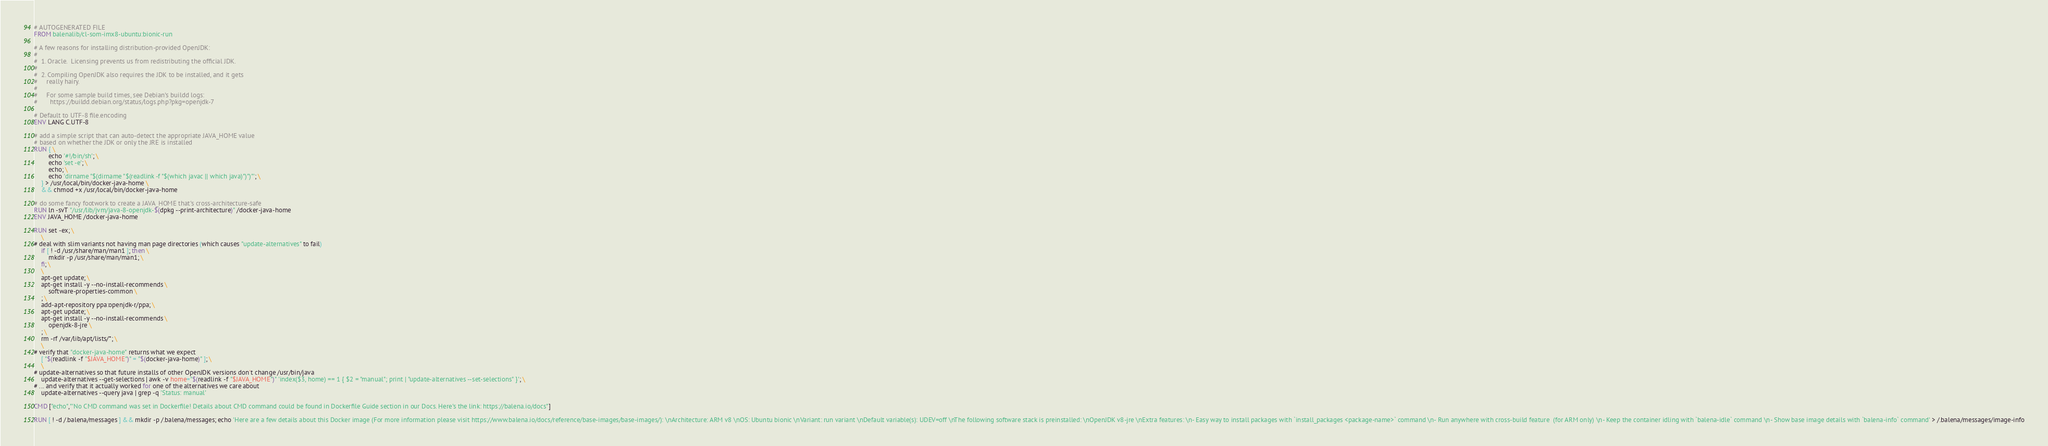Convert code to text. <code><loc_0><loc_0><loc_500><loc_500><_Dockerfile_># AUTOGENERATED FILE
FROM balenalib/cl-som-imx8-ubuntu:bionic-run

# A few reasons for installing distribution-provided OpenJDK:
#
#  1. Oracle.  Licensing prevents us from redistributing the official JDK.
#
#  2. Compiling OpenJDK also requires the JDK to be installed, and it gets
#     really hairy.
#
#     For some sample build times, see Debian's buildd logs:
#       https://buildd.debian.org/status/logs.php?pkg=openjdk-7

# Default to UTF-8 file.encoding
ENV LANG C.UTF-8

# add a simple script that can auto-detect the appropriate JAVA_HOME value
# based on whether the JDK or only the JRE is installed
RUN { \
		echo '#!/bin/sh'; \
		echo 'set -e'; \
		echo; \
		echo 'dirname "$(dirname "$(readlink -f "$(which javac || which java)")")"'; \
	} > /usr/local/bin/docker-java-home \
	&& chmod +x /usr/local/bin/docker-java-home

# do some fancy footwork to create a JAVA_HOME that's cross-architecture-safe
RUN ln -svT "/usr/lib/jvm/java-8-openjdk-$(dpkg --print-architecture)" /docker-java-home
ENV JAVA_HOME /docker-java-home

RUN set -ex; \
	\
# deal with slim variants not having man page directories (which causes "update-alternatives" to fail)
	if [ ! -d /usr/share/man/man1 ]; then \
		mkdir -p /usr/share/man/man1; \
	fi; \
	\
	apt-get update; \
	apt-get install -y --no-install-recommends \
		software-properties-common \
	; \
	add-apt-repository ppa:openjdk-r/ppa; \
	apt-get update; \
	apt-get install -y --no-install-recommends \
		openjdk-8-jre \
	; \
	rm -rf /var/lib/apt/lists/*; \
	\
# verify that "docker-java-home" returns what we expect
	[ "$(readlink -f "$JAVA_HOME")" = "$(docker-java-home)" ]; \
	\
# update-alternatives so that future installs of other OpenJDK versions don't change /usr/bin/java
	update-alternatives --get-selections | awk -v home="$(readlink -f "$JAVA_HOME")" 'index($3, home) == 1 { $2 = "manual"; print | "update-alternatives --set-selections" }'; \
# ... and verify that it actually worked for one of the alternatives we care about
	update-alternatives --query java | grep -q 'Status: manual'

CMD ["echo","'No CMD command was set in Dockerfile! Details about CMD command could be found in Dockerfile Guide section in our Docs. Here's the link: https://balena.io/docs"]

RUN [ ! -d /.balena/messages ] && mkdir -p /.balena/messages; echo 'Here are a few details about this Docker image (For more information please visit https://www.balena.io/docs/reference/base-images/base-images/): \nArchitecture: ARM v8 \nOS: Ubuntu bionic \nVariant: run variant \nDefault variable(s): UDEV=off \nThe following software stack is preinstalled: \nOpenJDK v8-jre \nExtra features: \n- Easy way to install packages with `install_packages <package-name>` command \n- Run anywhere with cross-build feature  (for ARM only) \n- Keep the container idling with `balena-idle` command \n- Show base image details with `balena-info` command' > /.balena/messages/image-info</code> 